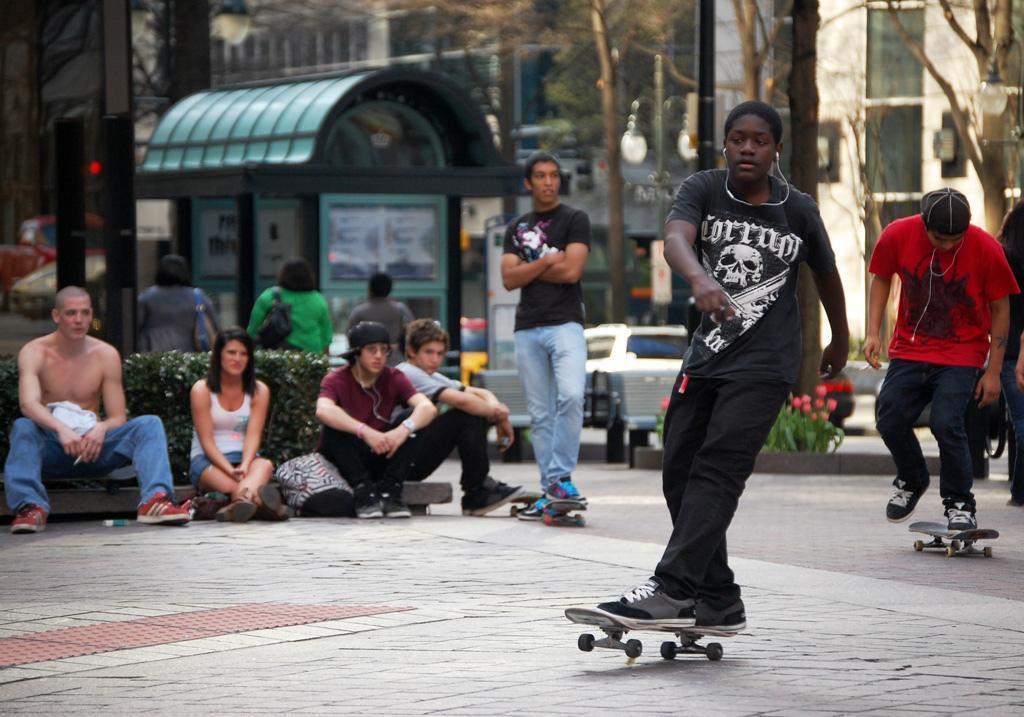How many people have skateboards?
Give a very brief answer. 4. 